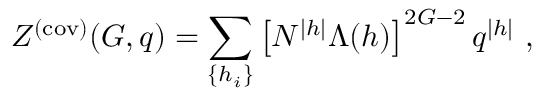<formula> <loc_0><loc_0><loc_500><loc_500>Z ^ { ( c o v ) } ( G , q ) = \sum _ { \{ h _ { i } \} } \left [ N ^ { | h | } \Lambda ( h ) \right ] ^ { 2 G - 2 } q ^ { | h | } ,</formula> 